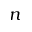<formula> <loc_0><loc_0><loc_500><loc_500>n</formula> 